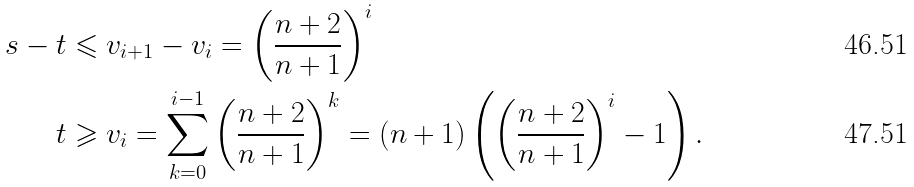Convert formula to latex. <formula><loc_0><loc_0><loc_500><loc_500>s - t & \leqslant v _ { i + 1 } - v _ { i } = \left ( \frac { n + 2 } { n + 1 } \right ) ^ { i } \\ t & \geqslant v _ { i } = \sum _ { k = 0 } ^ { i - 1 } \left ( \frac { n + 2 } { n + 1 } \right ) ^ { k } = ( n + 1 ) \left ( \left ( \frac { n + 2 } { n + 1 } \right ) ^ { i } - 1 \right ) .</formula> 